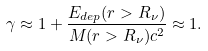<formula> <loc_0><loc_0><loc_500><loc_500>\gamma \approx 1 + \frac { E _ { d e p } ( r > R _ { \nu } ) } { M ( r > R _ { \nu } ) c ^ { 2 } } \approx 1 .</formula> 